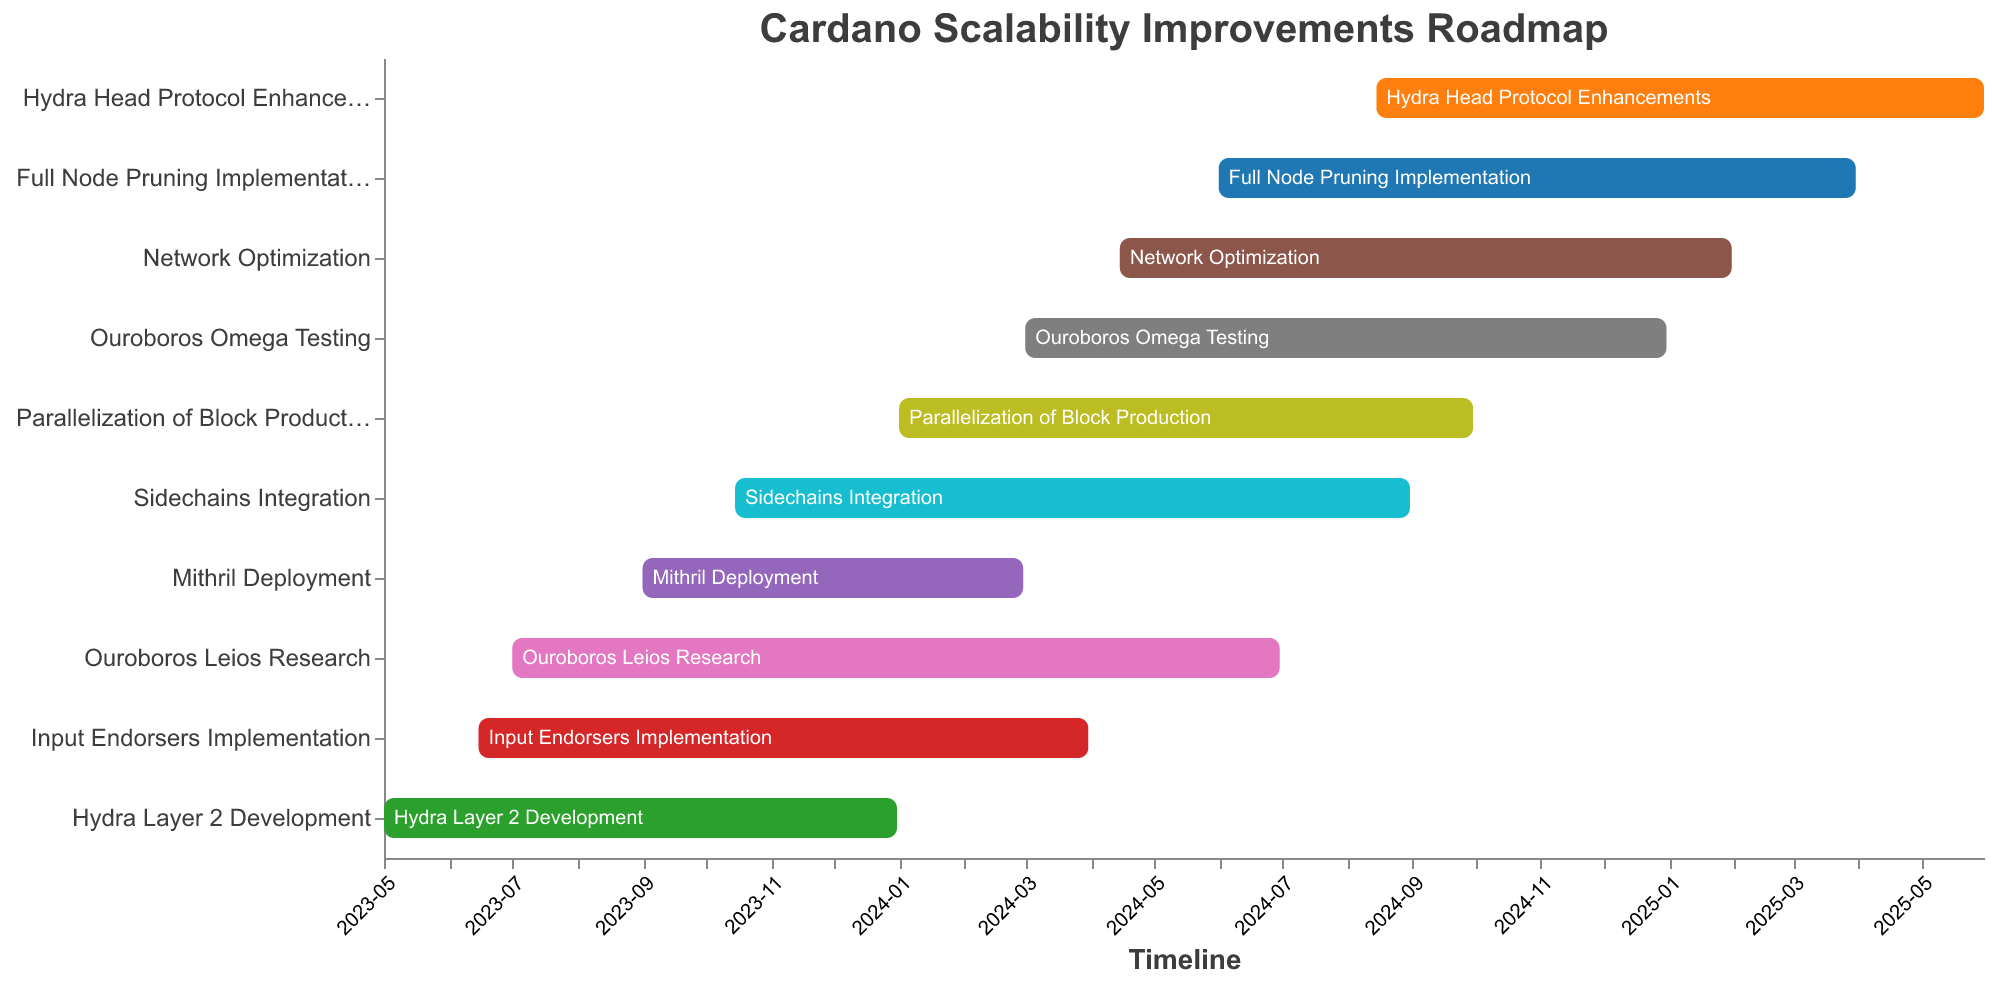What is the title of the Gantt chart? The title is placed on top of the chart and it can be easily read.
Answer: Cardano Scalability Improvements Roadmap Which task starts earliest in the roadmap? By looking at the start dates on the timeline, the earliest start date is shown for "Hydra Layer 2 Development".
Answer: Hydra Layer 2 Development What is the last task to end in the roadmap? By examining the end dates on the timeline, the last task to end is "Hydra Head Protocol Enhancements".
Answer: Hydra Head Protocol Enhancements How many tasks start in 2023? By reviewing the start dates column and counting tasks starting in 2023, we notice six tasks. These tasks are "Hydra Layer 2 Development", "Input Endorsers Implementation", "Ouroboros Leios Research", "Mithril Deployment", "Sidechains Integration", and "Parallelization of Block Production".
Answer: 6 What tasks are scheduled to start after "Input Endorsers Implementation" begins? Referring to the start dates of all tasks, anything starting after June 15, 2023, will be considered. These tasks are "Ouroboros Leios Research", "Mithril Deployment", "Sidechains Integration", "Parallelization of Block Production", "Ouroboros Omega Testing", "Network Optimization", "Full Node Pruning Implementation", and "Hydra Head Protocol Enhancements".
Answer: 8 tasks Which task has the longest duration? By computing the duration as the difference between the end and start dates for all tasks, the task with the longest duration is "Full Node Pruning Implementation" which spans from June 1, 2024, to March 31, 2025, totaling approximately 10 months.
Answer: Full Node Pruning Implementation Which tasks overlap in the timeline with "Sidechains Integration"? By evaluating the start and end dates of all tasks relative to "Sidechains Integration" (October 15, 2023, to August 31, 2024), the overlapping tasks are "Parallelization of Block Production", "Ouroboros Omega Testing", "Network Optimization", and "Full Node Pruning Implementation".
Answer: 4 tasks Between "Hydra Layer 2 Development" and "Mithril Deployment", which task finishes first? Checking the end dates of both tasks, "Hydra Layer 2 Development" ends on December 31, 2023, while "Mithril Deployment" ends on February 29, 2024. Therefore, "Hydra Layer 2 Development" finishes first.
Answer: Hydra Layer 2 Development Which tasks are scheduled to finish in 2024? Locating the tasks with end dates within the year 2024, we find "Input Endorsers Implementation", "Ouroboros Leios Research", "Mithril Deployment", "Sidechains Integration", "Parallelization of Block Production", and "Ouroboros Omega Testing".
Answer: 6 tasks 